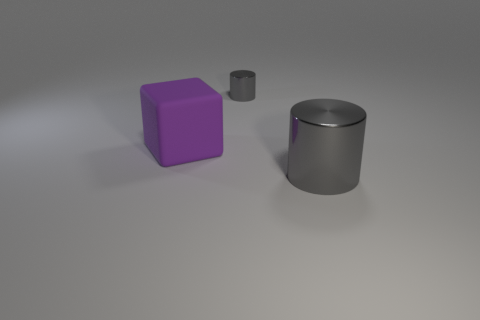What is the material of the tiny object that is the same shape as the large gray object?
Your answer should be very brief. Metal. There is a object that is on the left side of the tiny thing; is it the same shape as the tiny object?
Offer a terse response. No. Is there anything else that has the same size as the matte block?
Your answer should be very brief. Yes. Are there fewer large purple rubber objects that are behind the large metallic cylinder than purple rubber things that are in front of the big purple matte object?
Provide a short and direct response. No. What number of other things are the same shape as the small thing?
Offer a terse response. 1. There is a shiny object in front of the gray object to the left of the gray metallic cylinder in front of the small gray cylinder; what is its size?
Your answer should be compact. Large. What number of purple things are either matte blocks or big things?
Keep it short and to the point. 1. What shape is the metallic object that is behind the gray shiny object in front of the big purple matte cube?
Make the answer very short. Cylinder. Do the gray thing that is to the left of the large gray shiny object and the gray metallic cylinder that is to the right of the small gray shiny thing have the same size?
Your response must be concise. No. Are there any large purple cubes that have the same material as the large cylinder?
Make the answer very short. No. 